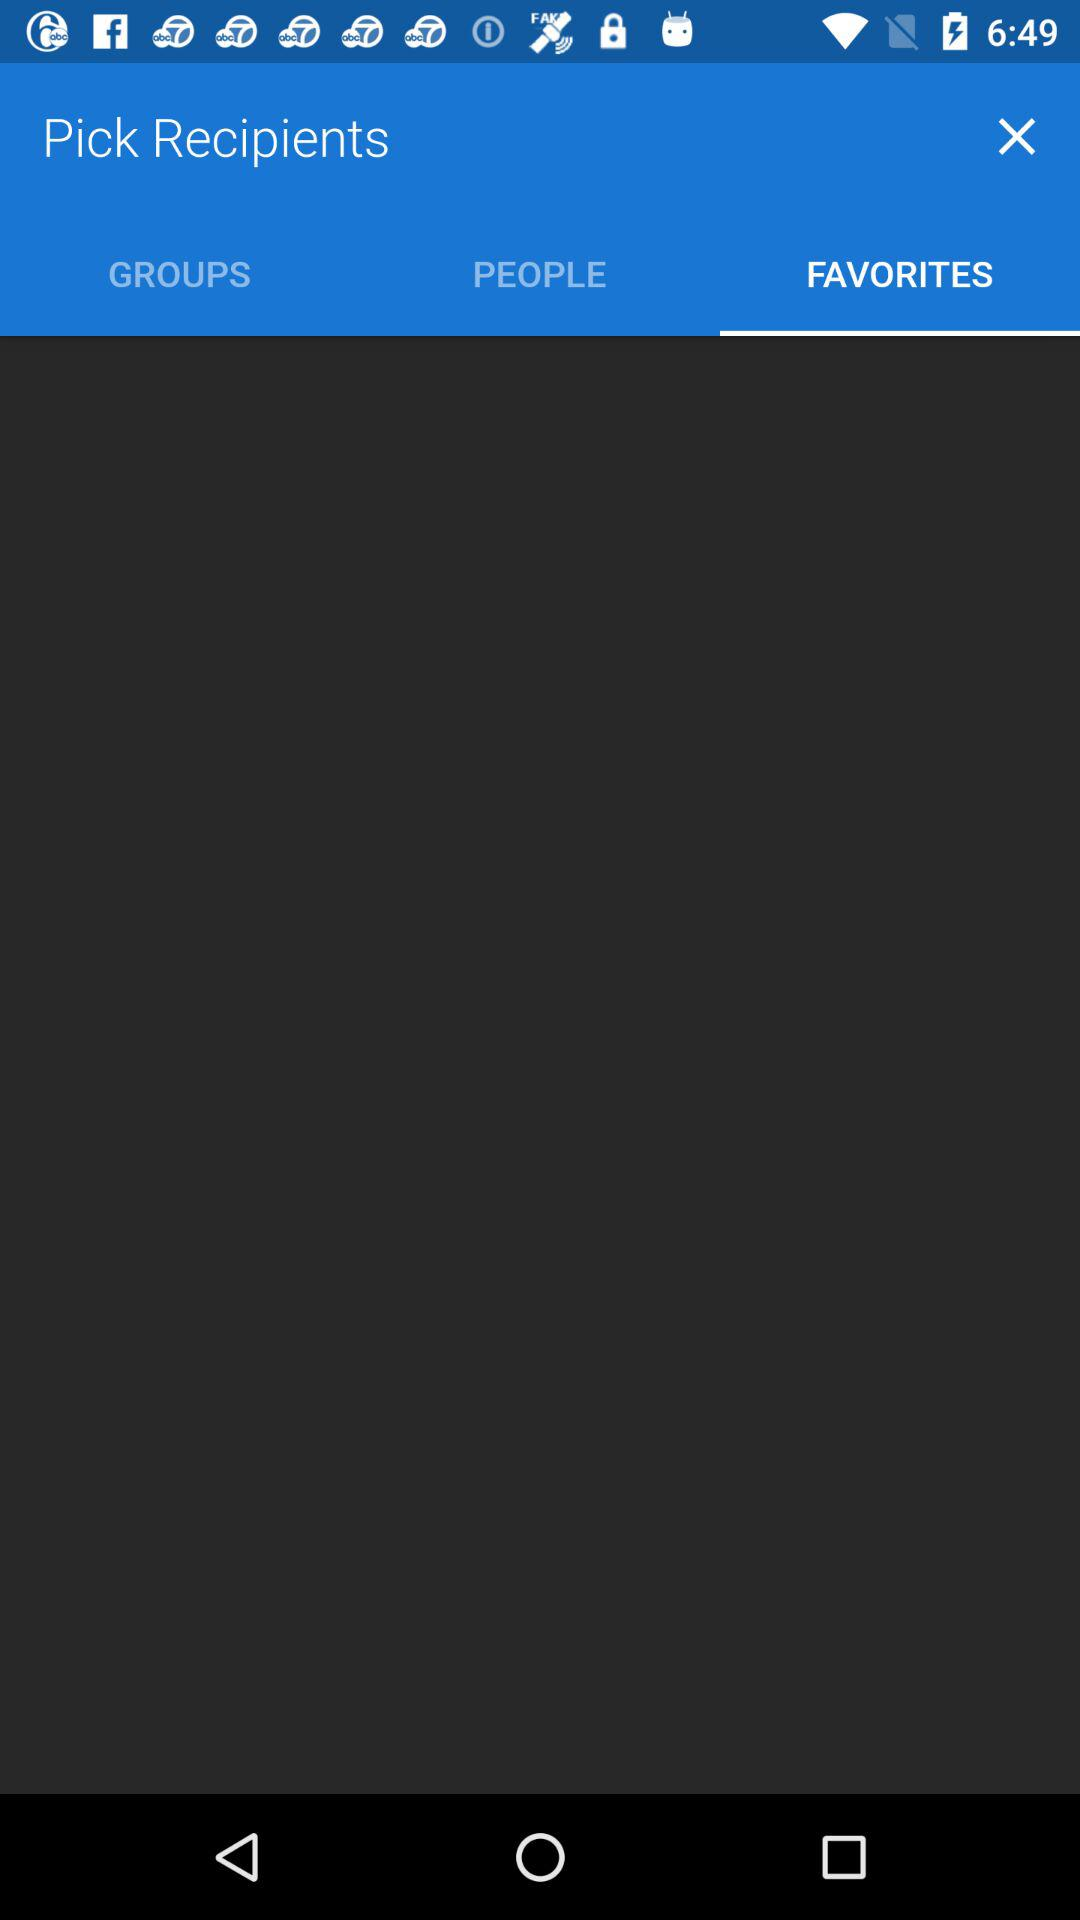What is the selected tab? The selected tab is "FAVORITES". 